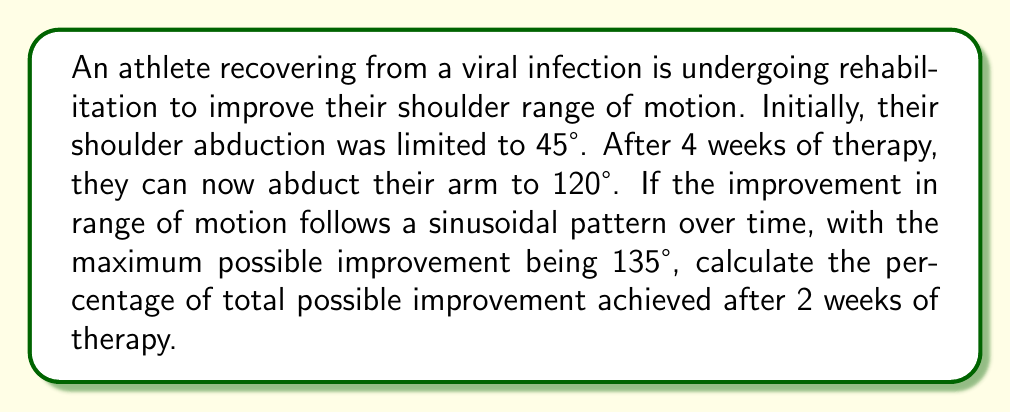Can you solve this math problem? Let's approach this step-by-step:

1) First, we need to model the improvement in range of motion over time. We can use a sine function:

   $$R(t) = A \sin(\frac{\pi t}{8}) + 45$$

   Where $R(t)$ is the range of motion at time $t$ (in weeks), and $A$ is the amplitude.

2) We know that at $t=4$, $R(4) = 120°$. Let's use this to find $A$:

   $$120 = A \sin(\frac{\pi \cdot 4}{8}) + 45$$
   $$120 = A \sin(\frac{\pi}{2}) + 45$$
   $$120 = A + 45$$
   $$A = 75$$

3) So our function is:

   $$R(t) = 75 \sin(\frac{\pi t}{8}) + 45$$

4) Now, we can calculate the range of motion at 2 weeks:

   $$R(2) = 75 \sin(\frac{\pi \cdot 2}{8}) + 45$$
   $$R(2) = 75 \sin(\frac{\pi}{4}) + 45$$
   $$R(2) = 75 \cdot \frac{\sqrt{2}}{2} + 45$$
   $$R(2) \approx 98.03°$$

5) The total improvement at 2 weeks is:

   $$98.03° - 45° = 53.03°$$

6) The maximum possible improvement is:

   $$135° - 45° = 90°$$

7) The percentage of total possible improvement is:

   $$\frac{53.03}{90} \cdot 100\% \approx 58.92\%$$
Answer: 58.92% 